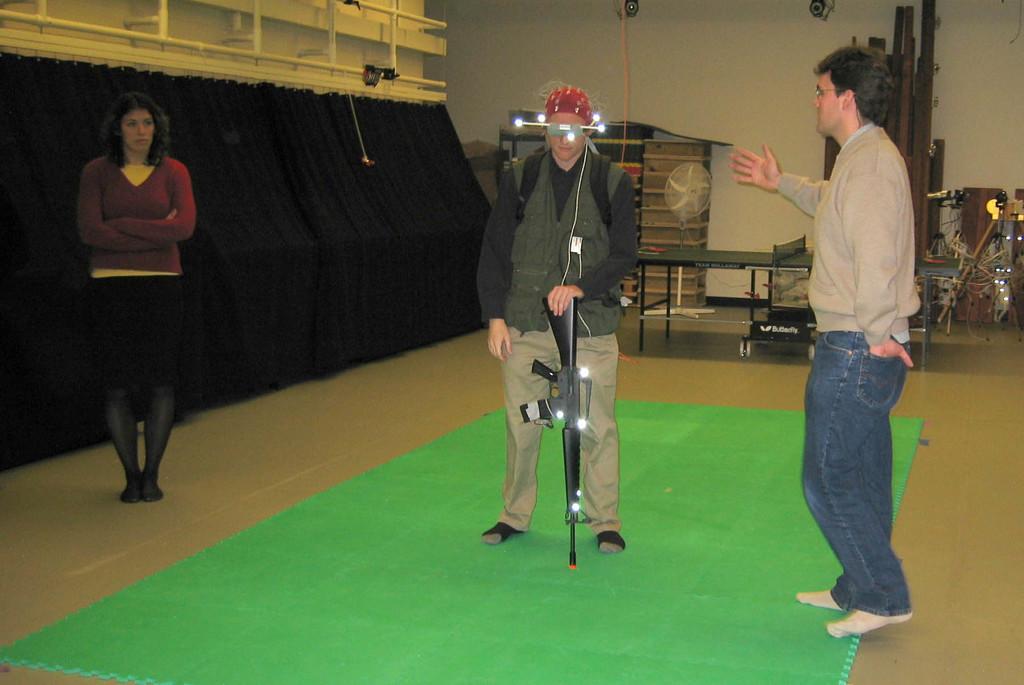Describe this image in one or two sentences. In this image, I can see three persons standing. Among them one person is holding a gun and there are lights on his head. In the background, I can see a pedestal fan, table tennis board , few other objects and there is a wall. On the left side of the image, I can see the curtains hanging to a hanger. At the bottom of the image, I can see a mat on the floor. 